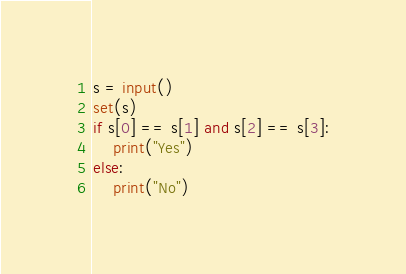Convert code to text. <code><loc_0><loc_0><loc_500><loc_500><_Python_>s = input()
set(s)
if s[0] == s[1] and s[2] == s[3]:
    print("Yes")
else:
    print("No")</code> 